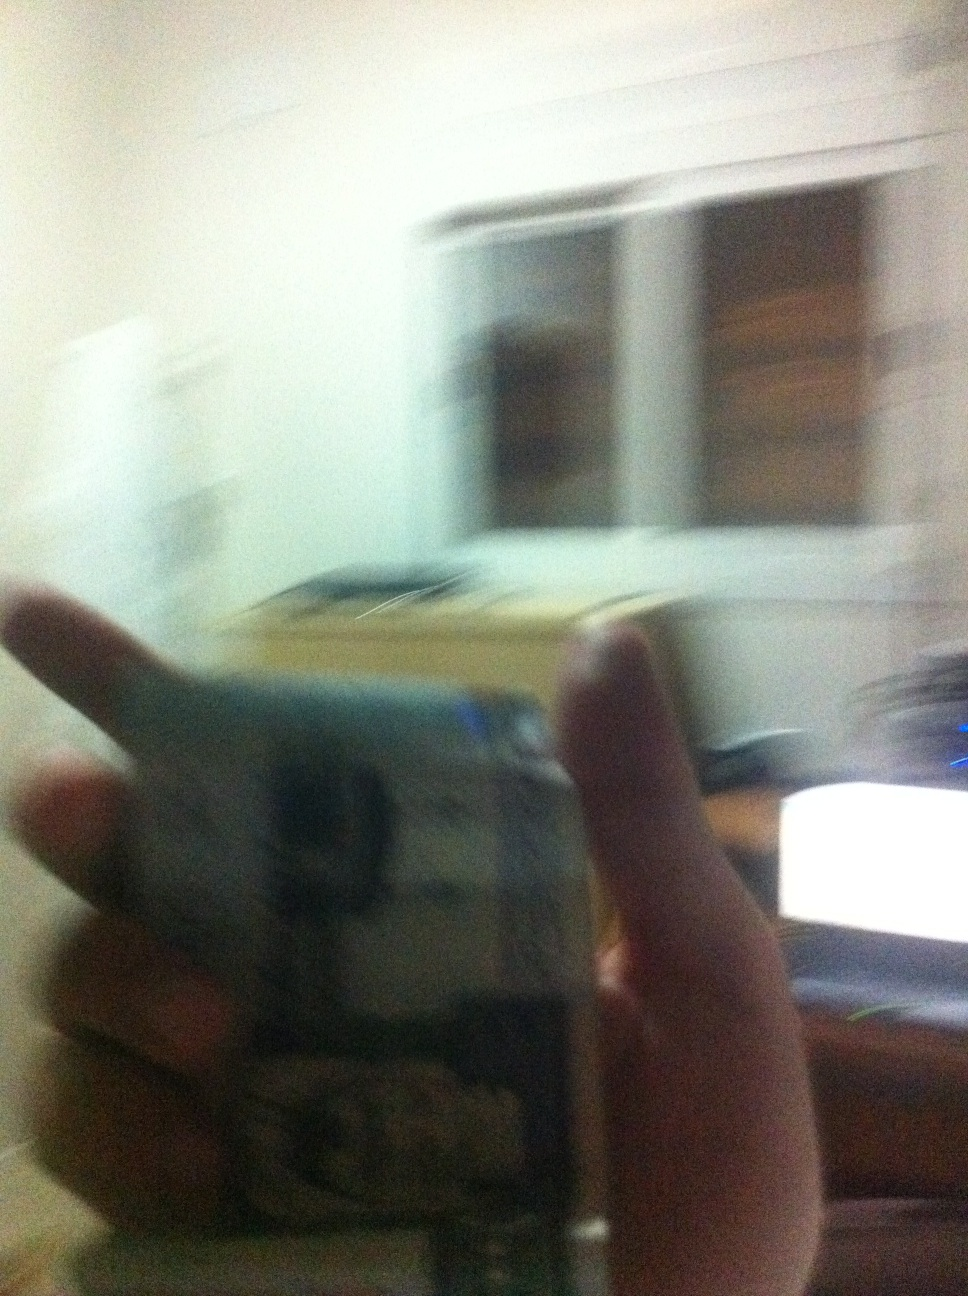Describe a possible scenario that could take place in the room shown in the image. In the room depicted in the image, a person could be preparing to work from home. They might be setting up their computer on the desk, preparing documents, and readying themselves for a day of productive activity. The quiet ambiance of the room might offer a perfect environment for concentration and focus on their tasks. 